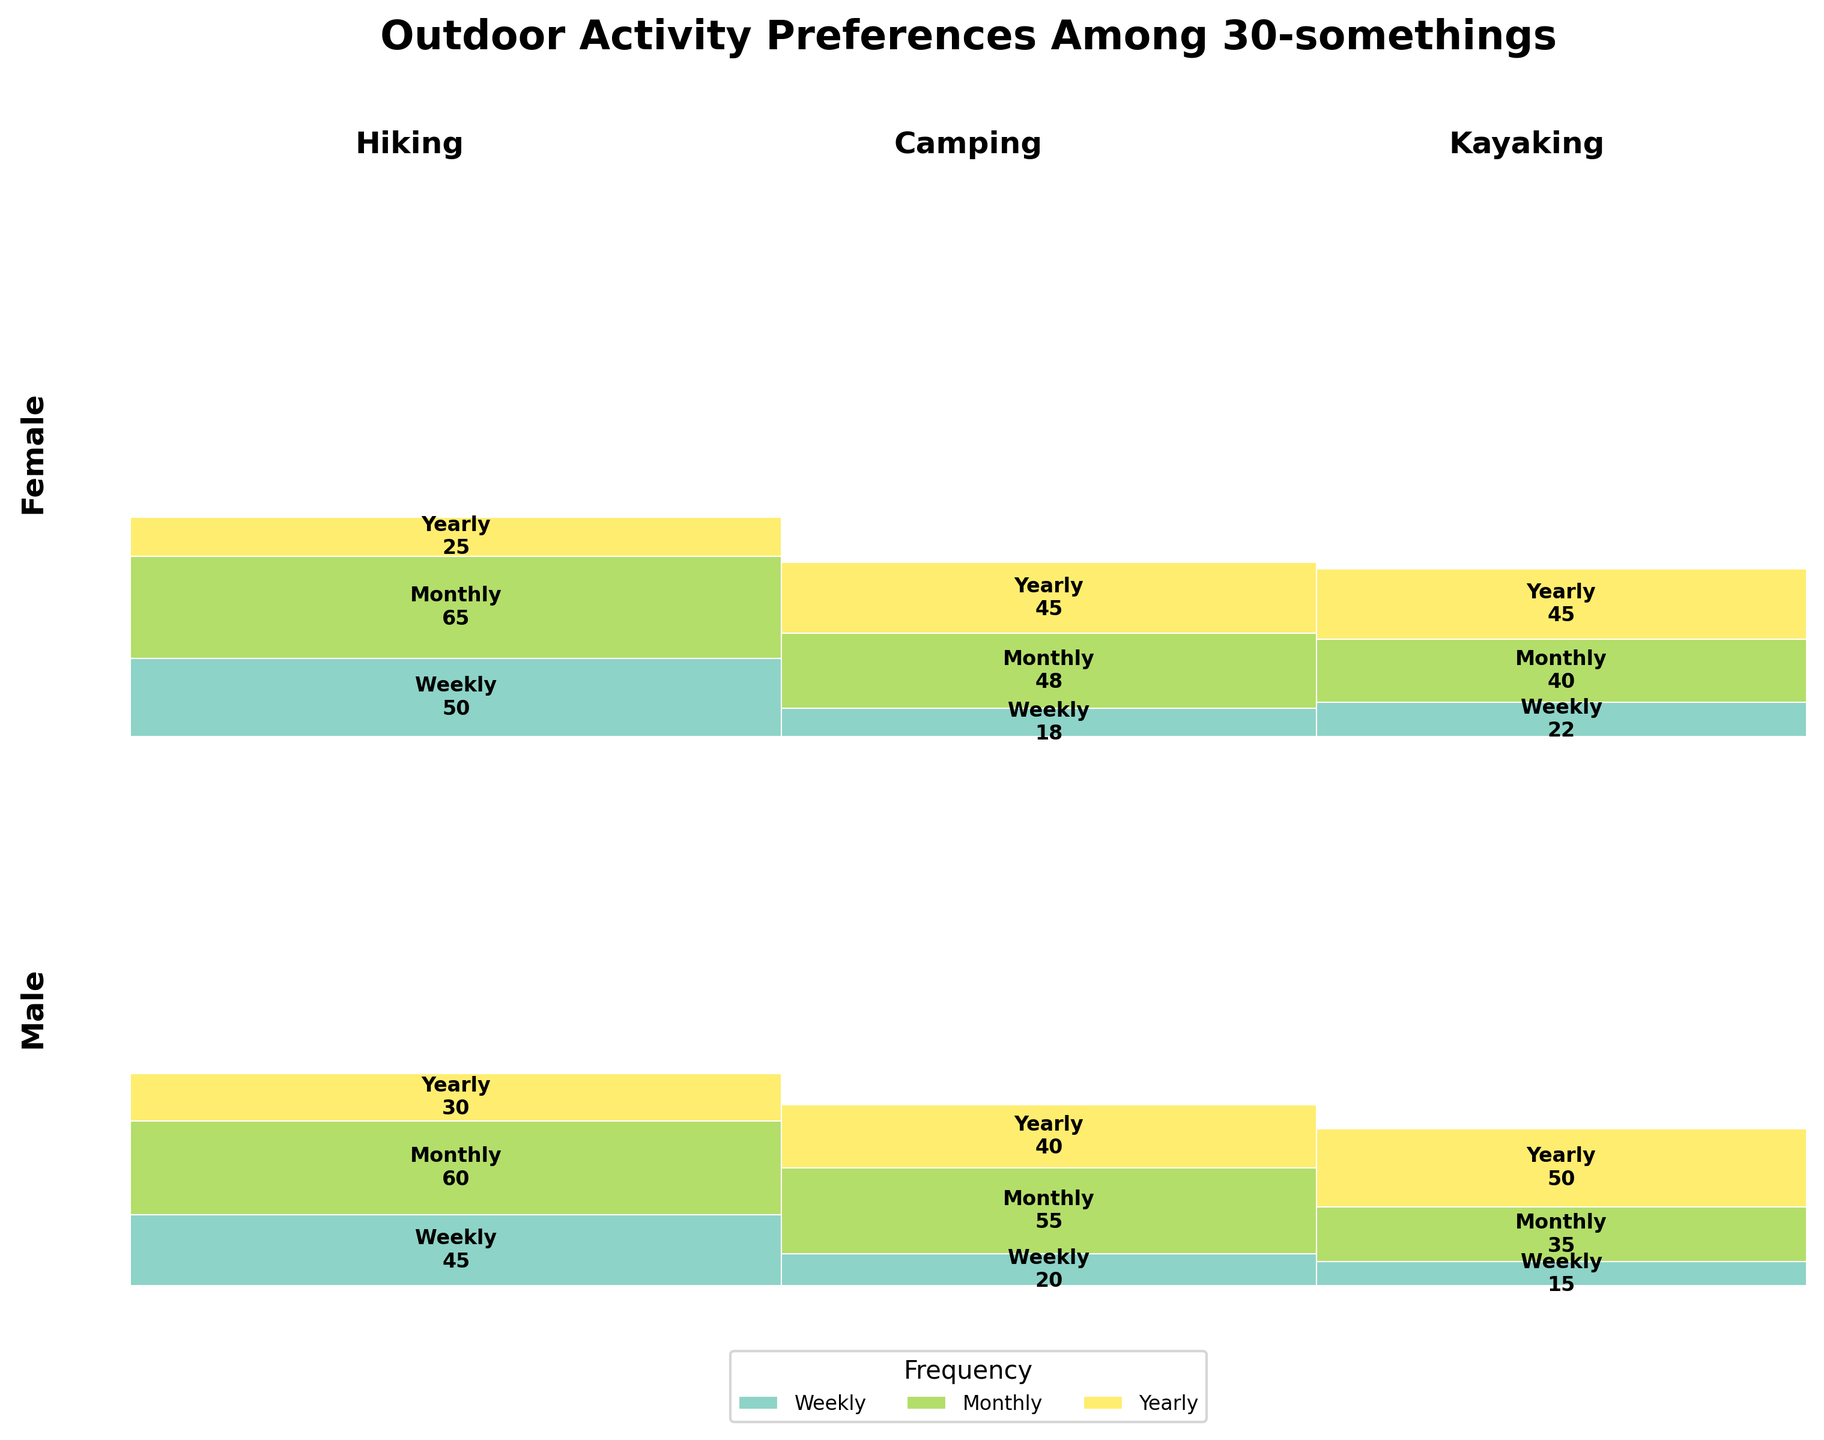What are the three outdoor activities displayed in the figure? The title and the x-axis labels of the figure indicate the activities. The labels are "Hiking," "Camping," and "Kayaking."
Answer: Hiking, Camping, Kayaking Which gender has a higher count for weekly hiking? By comparing the "Hiking" sections for both genders, the rectangles marked "Weekly" for hiking have a higher count for females (50) than for males (45).
Answer: Female What is the total count of people who go kayaking yearly? Add the counts for both genders who go kayaking yearly. From the plot, the counts are 50 for males and 45 for females, totaling 50 + 45 = 95.
Answer: 95 For which activity and frequency combination do males have the lowest count? Observe all the rectangles for males and find the smallest count. "Kayaking Weekly" has the smallest rectangle with a count of 15.
Answer: Kayaking Weekly Who participates more frequently in camping monthly, males or females? Compare the rectangles marked "Monthly" within the "Camping" sections for both genders. Males have a count of 55, while females have a count of 48, so males participate more frequently monthly.
Answer: Males Which activity has the least participation overall among 30-somethings? Add the total counts for each activity from both genders. Hiking (45+60+30 + 50+65+25 = 275), Camping (20+55+40 + 18+48+45 = 226), Kayaking (15+35+50 + 22+40+45 = 207). Kayaking has the least participation overall with a total count of 207.
Answer: Kayaking What percentage of females go hiking weekly? The count for females hiking weekly is 50. The total count for females (50+65+25 + 18+48+45 + 22+40+45 = 358). The percentage is (50/358)*100 ≈ 13.97%.
Answer: 13.97% Which activity and frequency combination has the closest counts between males and females? Compare the difference in counts for all activities/frequencies: Hiking (Weekly: 45-50=5, Monthly: 60-65=5, Yearly: 30-25=5), Camping (Weekly: 20-18=2, Monthly: 55-48=7, Yearly: 40-45=5), Kayaking (Weekly: 15-22=7, Monthly: 35-40=5, Yearly: 50-45=5). "Camping Weekly" has the smallest difference of 2.
Answer: Camping Weekly Which gender has a higher variation in camping frequency participation? Calculate the range (max-min) for dining counts in each gender: Males (20, 55, 40) → max-min=55-20=35; Females (18, 48, 45) → max-min=48-18=30. Males have a higher variation (35).
Answer: Males 